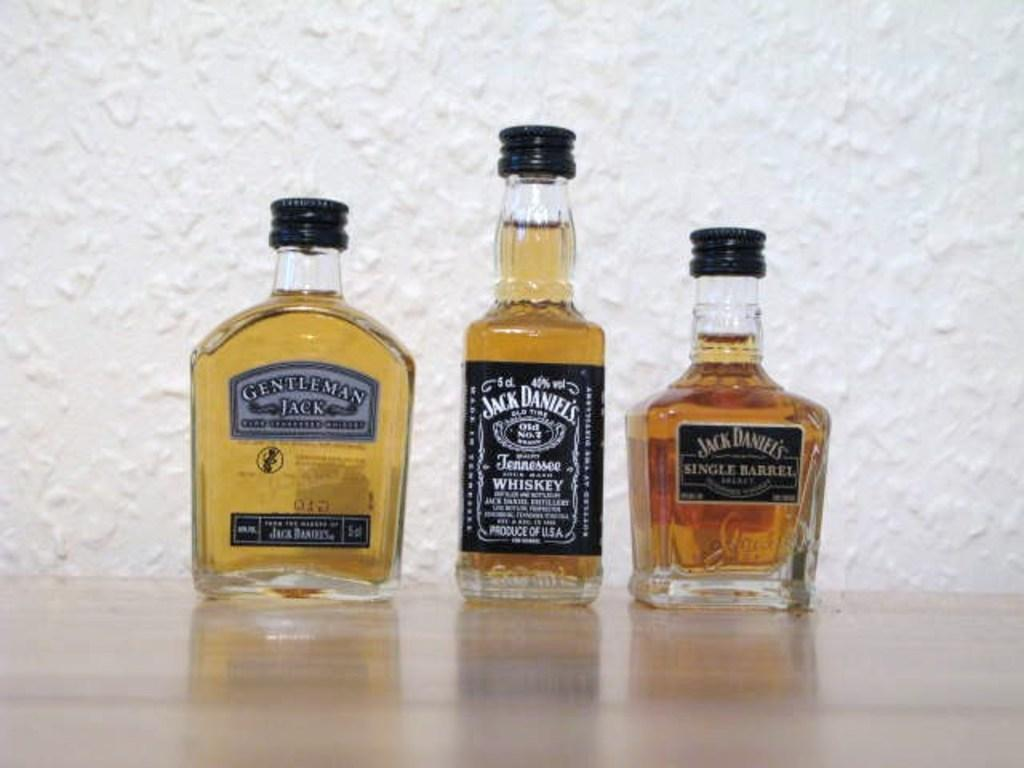<image>
Provide a brief description of the given image. Three different bottles of Jack Daniel's are lined up side by side. 